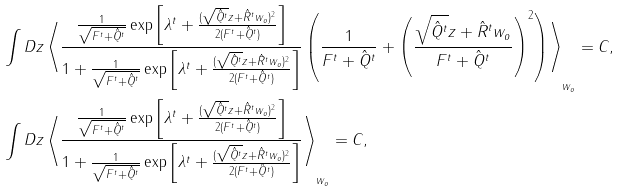Convert formula to latex. <formula><loc_0><loc_0><loc_500><loc_500>& \int D z \left \langle \frac { \frac { 1 } { \sqrt { F ^ { t } + \hat { Q } ^ { t } } } \exp \left [ \lambda ^ { t } + \frac { ( \sqrt { \hat { Q } ^ { t } } z + \hat { R } ^ { t } w _ { o } ) ^ { 2 } } { 2 ( F ^ { t } + \hat { Q } ^ { t } ) } \right ] } { 1 + \frac { 1 } { \sqrt { F ^ { t } + \hat { Q } ^ { t } } } \exp \left [ \lambda ^ { t } + \frac { ( \sqrt { \hat { Q } ^ { t } } z + \hat { R } ^ { t } w _ { o } ) ^ { 2 } } { 2 ( F ^ { t } + \hat { Q } ^ { t } ) } \right ] } \left ( \frac { 1 } { F ^ { t } + \hat { Q } ^ { t } } + \left ( \frac { \sqrt { \hat { Q } ^ { t } } z + \hat { R } ^ { t } w _ { o } } { F ^ { t } + \hat { Q } ^ { t } } \right ) ^ { 2 } \right ) \right \rangle _ { w _ { o } } = C , \\ & \int D z \left \langle \frac { \frac { 1 } { \sqrt { F ^ { t } + \hat { Q } ^ { t } } } \exp \left [ \lambda ^ { t } + \frac { ( \sqrt { \hat { Q } ^ { t } } z + \hat { R } ^ { t } w _ { o } ) ^ { 2 } } { 2 ( F ^ { t } + \hat { Q } ^ { t } ) } \right ] } { 1 + \frac { 1 } { \sqrt { F ^ { t } + \hat { Q } ^ { t } } } \exp \left [ \lambda ^ { t } + \frac { ( \sqrt { \hat { Q } ^ { t } } z + \hat { R } ^ { t } w _ { o } ) ^ { 2 } } { 2 ( F ^ { t } + \hat { Q } ^ { t } ) } \right ] } \right \rangle _ { w _ { o } } = C ,</formula> 